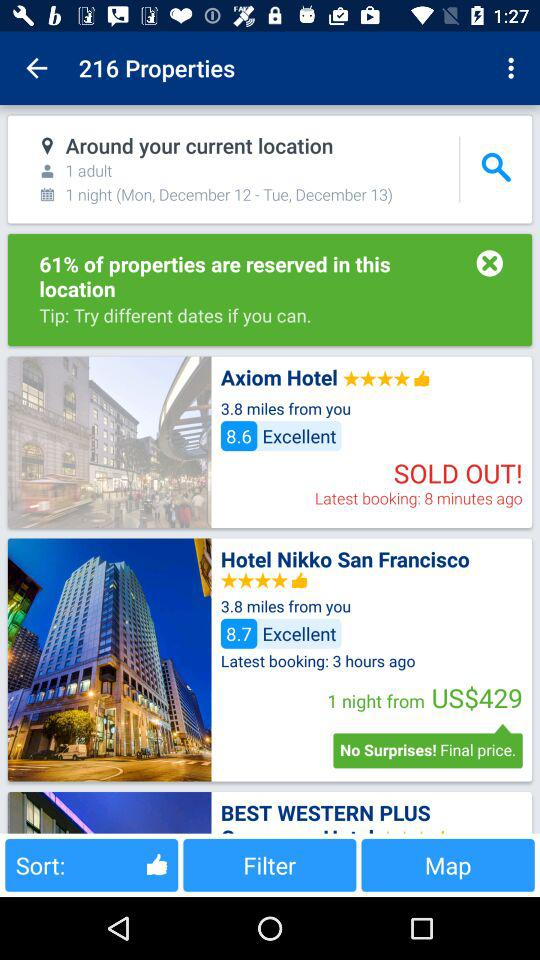What is the distance between the Axiom Hotel and my current location? The distance is 3.8 miles. 